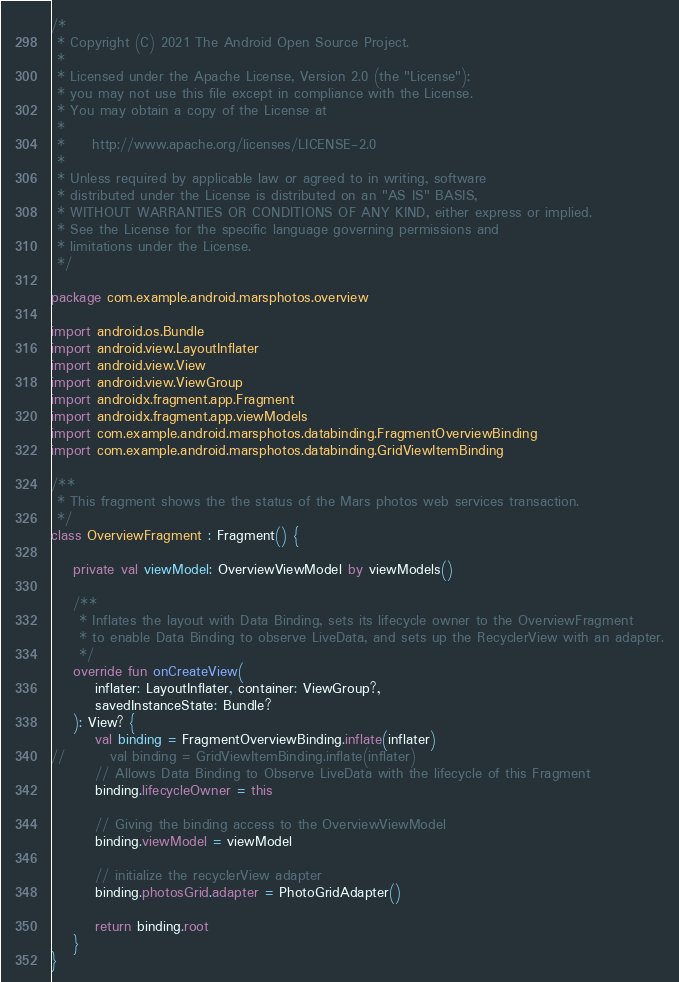Convert code to text. <code><loc_0><loc_0><loc_500><loc_500><_Kotlin_>/*
 * Copyright (C) 2021 The Android Open Source Project.
 *
 * Licensed under the Apache License, Version 2.0 (the "License");
 * you may not use this file except in compliance with the License.
 * You may obtain a copy of the License at
 *
 *     http://www.apache.org/licenses/LICENSE-2.0
 *
 * Unless required by applicable law or agreed to in writing, software
 * distributed under the License is distributed on an "AS IS" BASIS,
 * WITHOUT WARRANTIES OR CONDITIONS OF ANY KIND, either express or implied.
 * See the License for the specific language governing permissions and
 * limitations under the License.
 */

package com.example.android.marsphotos.overview

import android.os.Bundle
import android.view.LayoutInflater
import android.view.View
import android.view.ViewGroup
import androidx.fragment.app.Fragment
import androidx.fragment.app.viewModels
import com.example.android.marsphotos.databinding.FragmentOverviewBinding
import com.example.android.marsphotos.databinding.GridViewItemBinding

/**
 * This fragment shows the the status of the Mars photos web services transaction.
 */
class OverviewFragment : Fragment() {

    private val viewModel: OverviewViewModel by viewModels()

    /**
     * Inflates the layout with Data Binding, sets its lifecycle owner to the OverviewFragment
     * to enable Data Binding to observe LiveData, and sets up the RecyclerView with an adapter.
     */
    override fun onCreateView(
        inflater: LayoutInflater, container: ViewGroup?,
        savedInstanceState: Bundle?
    ): View? {
        val binding = FragmentOverviewBinding.inflate(inflater)
//        val binding = GridViewItemBinding.inflate(inflater)
        // Allows Data Binding to Observe LiveData with the lifecycle of this Fragment
        binding.lifecycleOwner = this

        // Giving the binding access to the OverviewViewModel
        binding.viewModel = viewModel

        // initialize the recyclerView adapter
        binding.photosGrid.adapter = PhotoGridAdapter()

        return binding.root
    }
}
</code> 